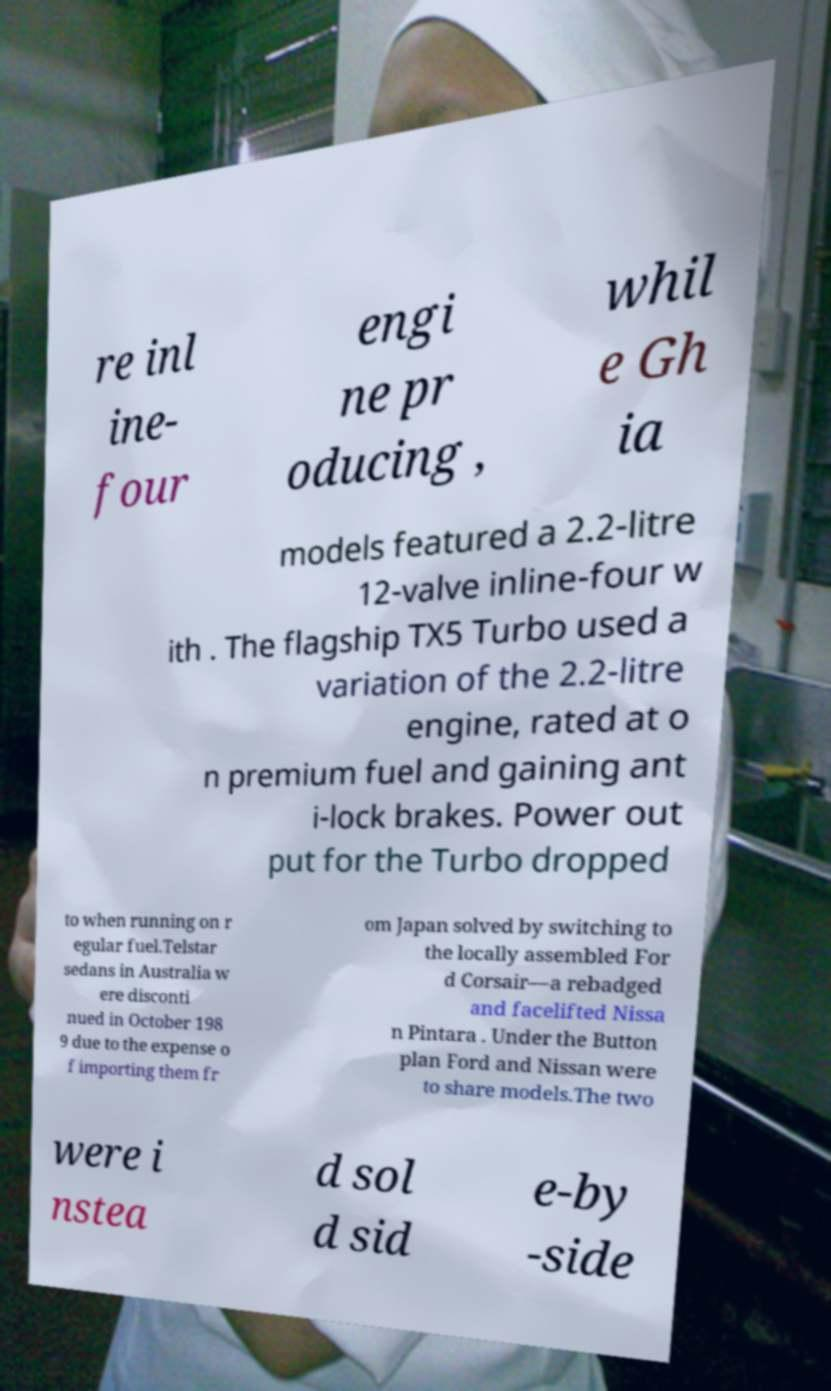Could you extract and type out the text from this image? re inl ine- four engi ne pr oducing , whil e Gh ia models featured a 2.2-litre 12-valve inline-four w ith . The flagship TX5 Turbo used a variation of the 2.2-litre engine, rated at o n premium fuel and gaining ant i-lock brakes. Power out put for the Turbo dropped to when running on r egular fuel.Telstar sedans in Australia w ere disconti nued in October 198 9 due to the expense o f importing them fr om Japan solved by switching to the locally assembled For d Corsair—a rebadged and facelifted Nissa n Pintara . Under the Button plan Ford and Nissan were to share models.The two were i nstea d sol d sid e-by -side 